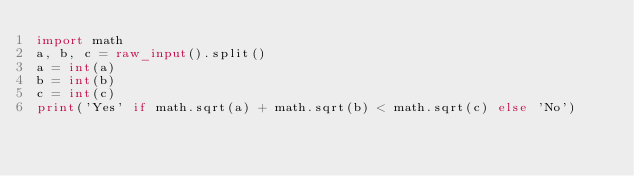<code> <loc_0><loc_0><loc_500><loc_500><_Python_>import math
a, b, c = raw_input().split()
a = int(a)
b = int(b)
c = int(c)
print('Yes' if math.sqrt(a) + math.sqrt(b) < math.sqrt(c) else 'No')
</code> 